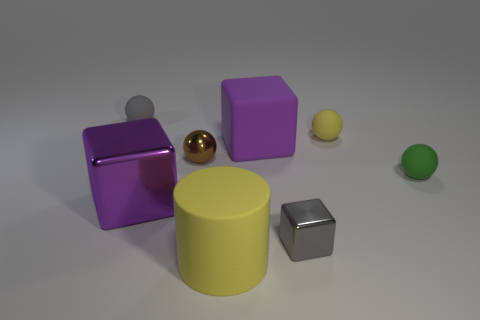Is the material of the yellow thing that is in front of the green thing the same as the small brown ball?
Your response must be concise. No. What material is the large purple cube in front of the brown metallic ball to the left of the small rubber thing in front of the small yellow rubber thing?
Your answer should be very brief. Metal. How many other things are there of the same shape as the small brown object?
Give a very brief answer. 3. What color is the tiny shiny thing that is to the right of the big yellow rubber cylinder?
Ensure brevity in your answer.  Gray. How many large shiny blocks are to the right of the tiny shiny object to the right of the matte object in front of the tiny green ball?
Offer a very short reply. 0. There is a tiny thing that is to the right of the small yellow object; how many large purple metal blocks are on the right side of it?
Make the answer very short. 0. There is a small gray metallic block; what number of matte objects are in front of it?
Your response must be concise. 1. How many other objects are the same size as the green matte sphere?
Offer a terse response. 4. There is a gray object that is the same shape as the tiny green object; what is its size?
Your answer should be very brief. Small. The big object behind the small brown metal object has what shape?
Ensure brevity in your answer.  Cube. 